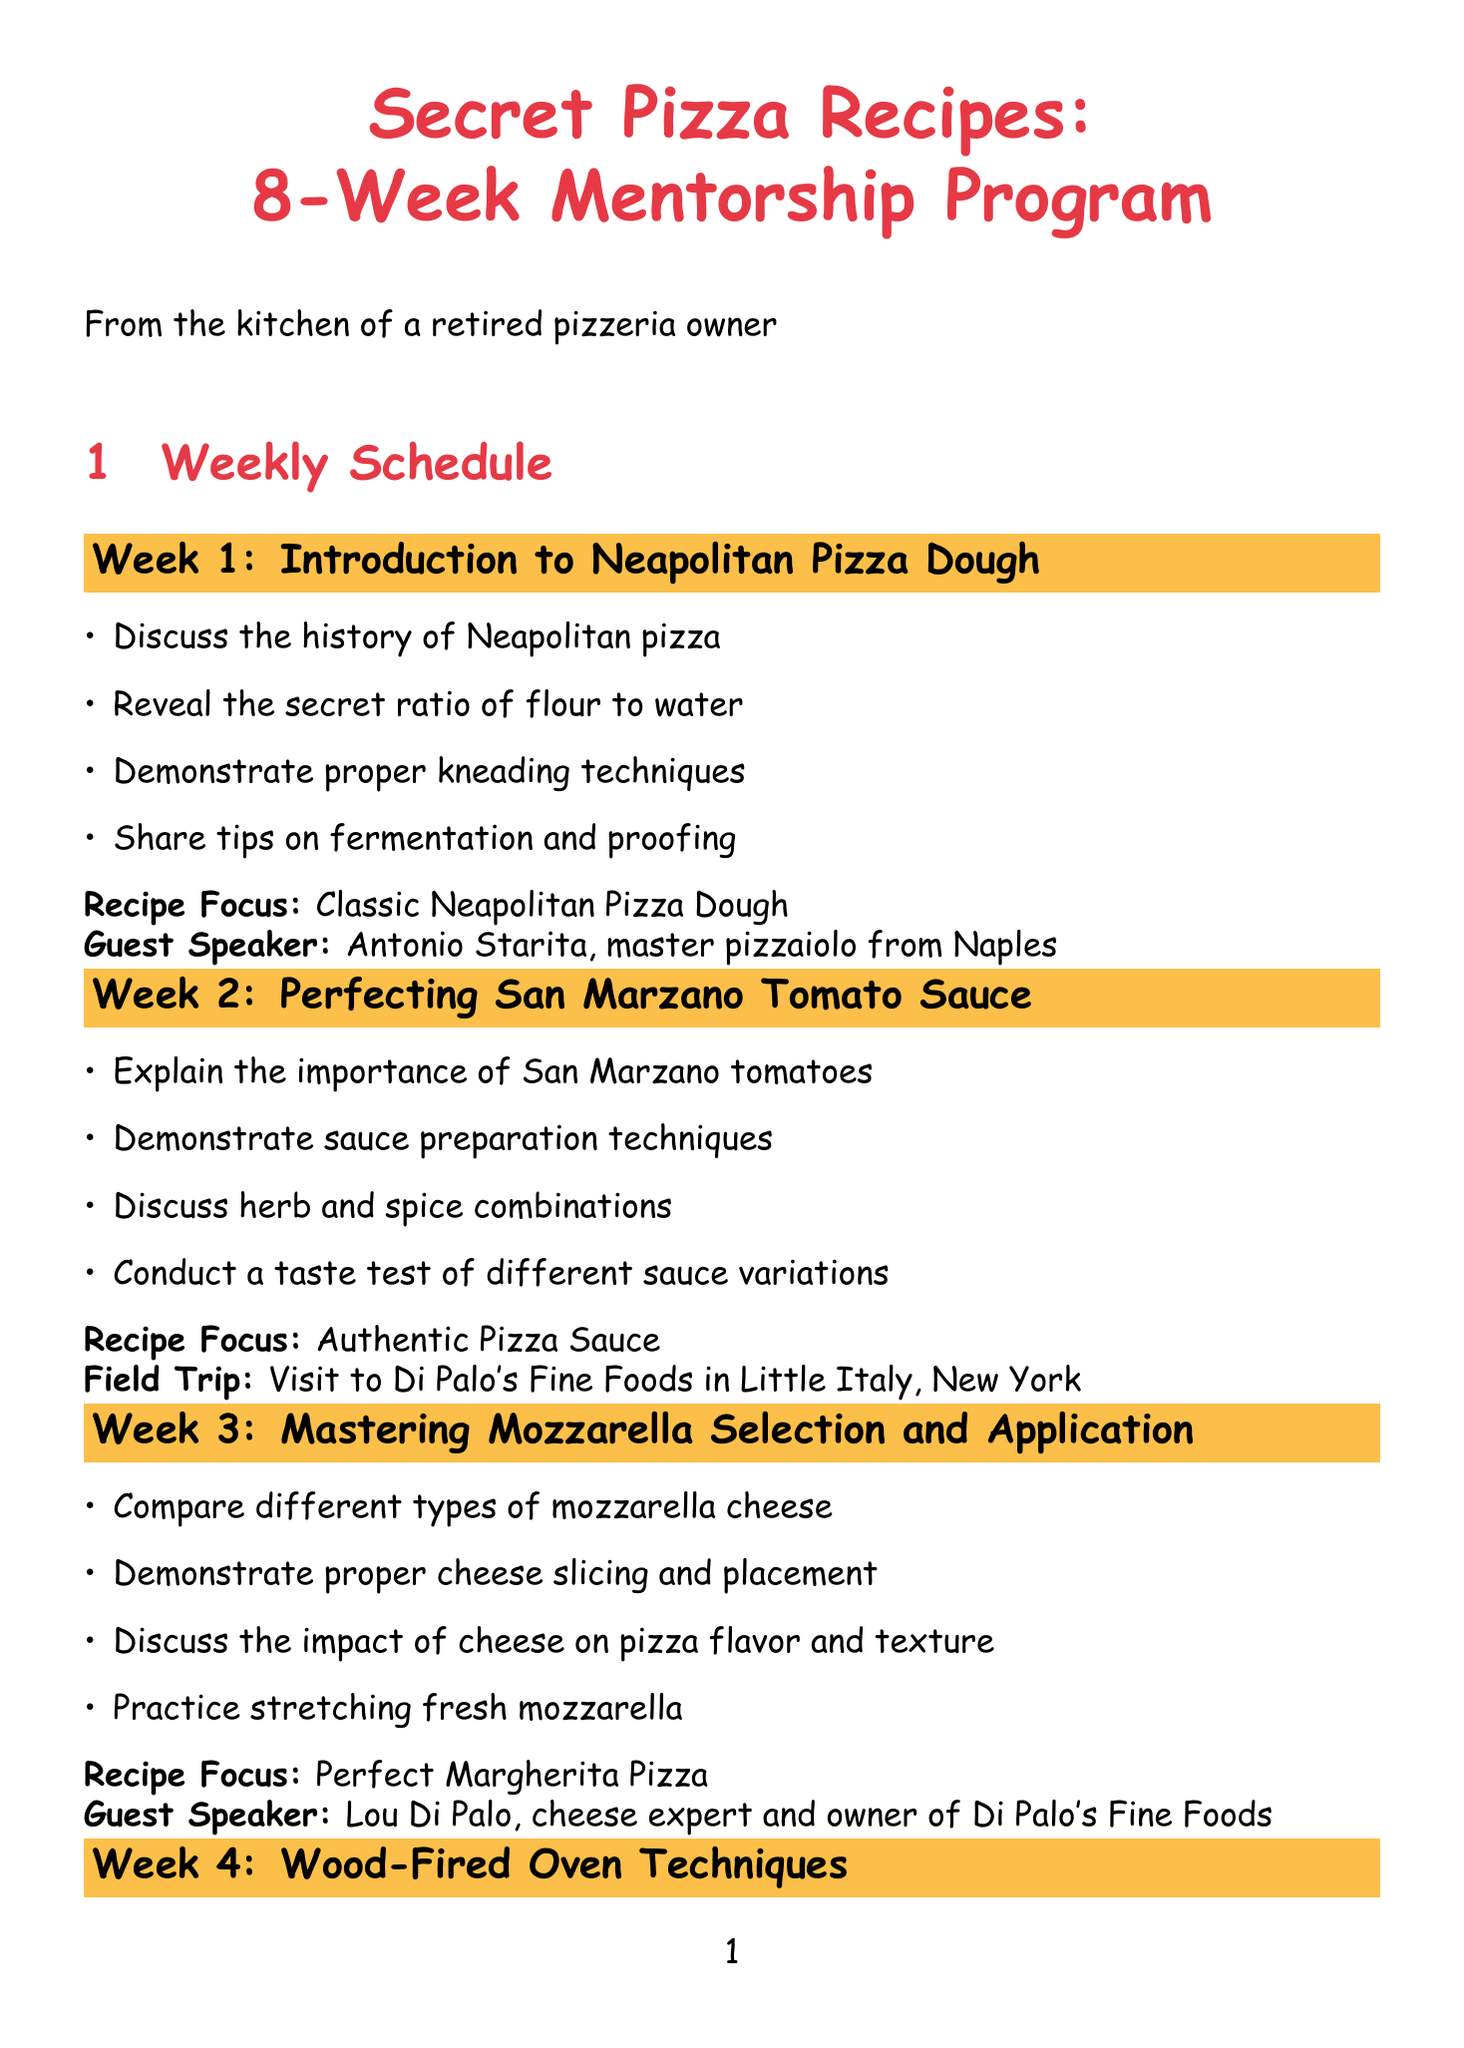What is the focus of Week 1? The focus of Week 1 is on the classic Neapolitan pizza dough, which is detailed in the first week's topic.
Answer: Classic Neapolitan Pizza Dough Who is the guest speaker in Week 3? The document specifies that Lou Di Palo is the guest speaker for Week 3, focusing on mozzarella selection.
Answer: Lou Di Palo What type of pizza is the focus of Week 5? The focus for Week 5 is unique toppings and their combinations, which leads to a specific pizza creation.
Answer: Prosciutto and Fig Pizza with Balsamic Glaze In which week do students create their signature pizza? The final project takes place in Week 8, where students develop their unique pizza recipes.
Answer: Week 8 What is the field trip location for Week 2? The document identifies that the field trip for Week 2 will take place at Di Palo's Fine Foods in Little Italy, New York.
Answer: Di Palo's Fine Foods in Little Italy, New York What is one activity planned for Week 6? The document notes that one planned activity for Week 6 is demonstrating vegan cheese preparation among other topics.
Answer: Demonstrate vegan cheese preparation How many weeks are in the mentorship program? The document explicitly states that there are eight weeks included in the mentorship program outlined.
Answer: Eight weeks What is shared during Week 1 regarding dough? The focus of the discussion in Week 1 includes a secret ratio of flour to water used for pizza dough.
Answer: Secret ratio of flour to water 